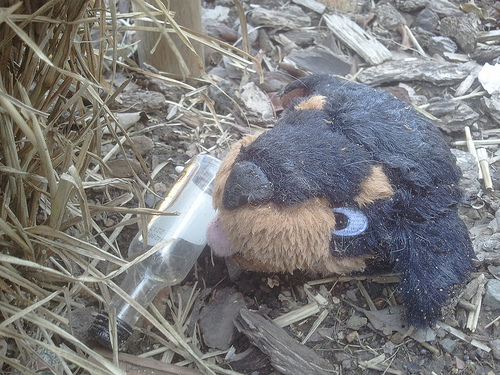<image>
Can you confirm if the dog is on the bottle? Yes. Looking at the image, I can see the dog is positioned on top of the bottle, with the bottle providing support. 